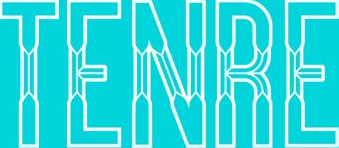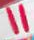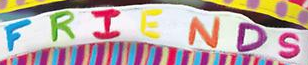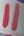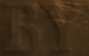What words can you see in these images in sequence, separated by a semicolon? TENRE; "; FRIENDS; "; BY 